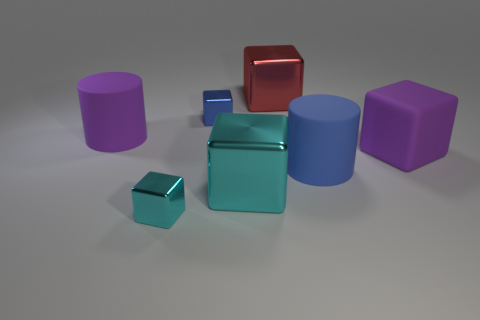What number of things are either purple matte objects on the left side of the tiny cyan metal block or big red blocks to the left of the large blue rubber cylinder?
Your answer should be very brief. 2. What is the color of the large rubber block?
Keep it short and to the point. Purple. Is the number of things that are left of the big red cube less than the number of small cyan metal cubes?
Offer a terse response. No. Are any small red matte blocks visible?
Your answer should be compact. No. Is the number of blue metal objects less than the number of large yellow rubber cylinders?
Your answer should be compact. No. How many cubes are made of the same material as the blue cylinder?
Provide a succinct answer. 1. What color is the other large cylinder that is the same material as the blue cylinder?
Your answer should be compact. Purple. The blue metallic thing has what shape?
Keep it short and to the point. Cube. How many large cylinders have the same color as the large matte block?
Offer a terse response. 1. There is a metallic thing that is the same size as the blue metallic block; what shape is it?
Offer a terse response. Cube. 